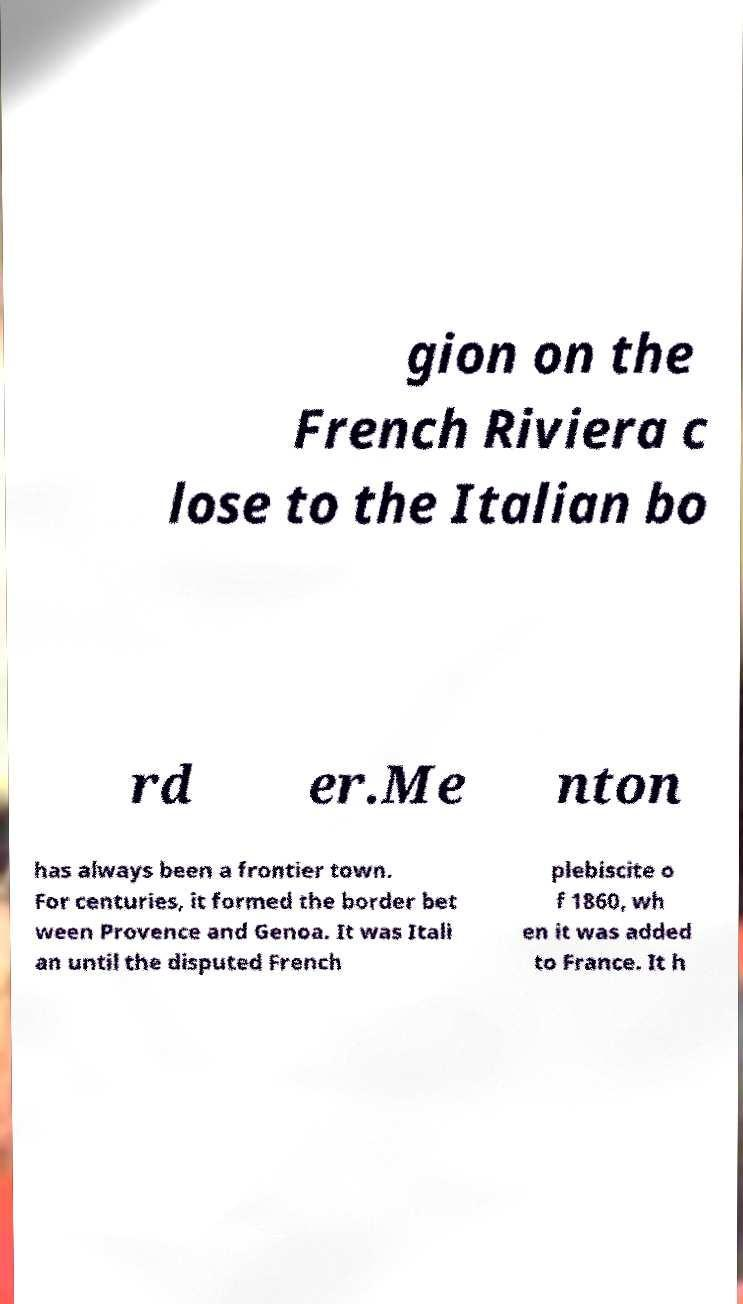Please identify and transcribe the text found in this image. gion on the French Riviera c lose to the Italian bo rd er.Me nton has always been a frontier town. For centuries, it formed the border bet ween Provence and Genoa. It was Itali an until the disputed French plebiscite o f 1860, wh en it was added to France. It h 